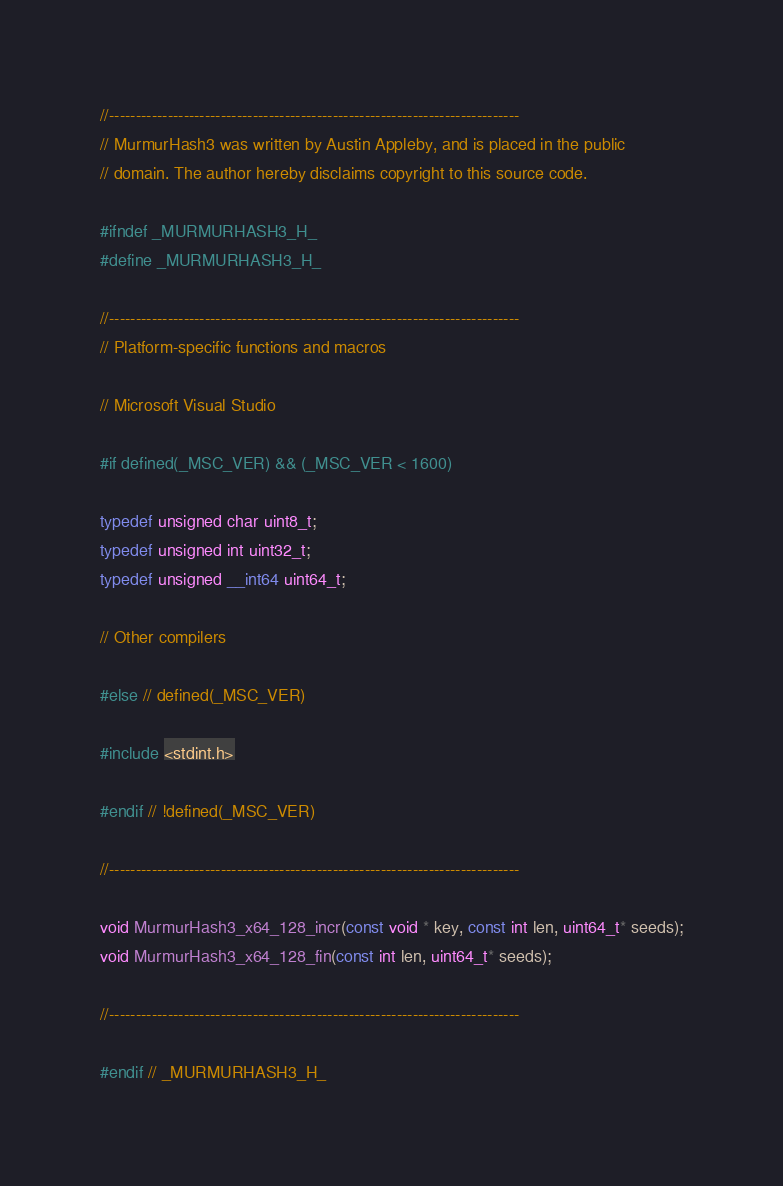<code> <loc_0><loc_0><loc_500><loc_500><_C_>//-----------------------------------------------------------------------------
// MurmurHash3 was written by Austin Appleby, and is placed in the public
// domain. The author hereby disclaims copyright to this source code.

#ifndef _MURMURHASH3_H_
#define _MURMURHASH3_H_

//-----------------------------------------------------------------------------
// Platform-specific functions and macros

// Microsoft Visual Studio

#if defined(_MSC_VER) && (_MSC_VER < 1600)

typedef unsigned char uint8_t;
typedef unsigned int uint32_t;
typedef unsigned __int64 uint64_t;

// Other compilers

#else // defined(_MSC_VER)

#include <stdint.h>

#endif // !defined(_MSC_VER)

//-----------------------------------------------------------------------------

void MurmurHash3_x64_128_incr(const void * key, const int len, uint64_t* seeds);
void MurmurHash3_x64_128_fin(const int len, uint64_t* seeds);

//-----------------------------------------------------------------------------

#endif // _MURMURHASH3_H_
</code> 